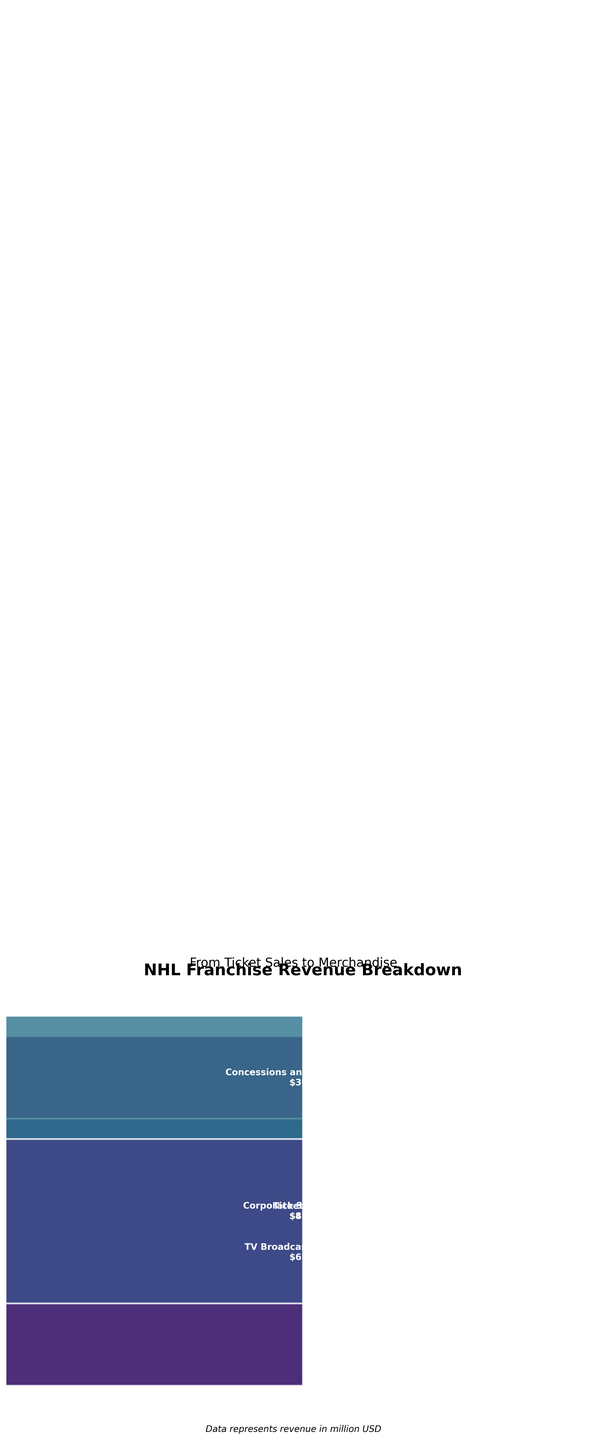What's the largest revenue stage displayed in the funnel chart? The funnel chart shows the breakdown of revenue from various stages, with the largest stage represented by the widest segment at the top. Observing the chart, the largest revenue stage is the first segment, which is labeled "Ticket Sales." The value provided is $85 million.
Answer: Ticket Sales What is the total revenue from concessions, merchandise sales, and parking fees? To find the total revenue from these three stages, we need to sum the values provided in the funnel chart: Concessions and Food Services generate $30 million, Merchandise Sales generate $25 million, and Parking Fees generate $10 million. The sum is 30 + 25 + 10.
Answer: $65 million Which stage has a higher revenue: Corporate Sponsorships or TV Broadcasting Rights? By comparing the height (and label) of the funnel segments, we see Corporate Sponsorships generate $45 million, whereas TV Broadcasting Rights generate $65 million. Therefore, TV Broadcasting Rights has a higher revenue.
Answer: TV Broadcasting Rights What is the average revenue of all the stages? To compute the average, we sum the revenue of all stages and divide by the number of stages. The total revenue is $85M + $65M + $45M + $30M + $25M + $10M + $8M + $5M = $273 million. There are 8 stages, so the average is 273 / 8.
Answer: $34.125 million By how much do ticket sales exceed merchandise sales? To determine this, we subtract the revenue from Merchandise Sales from Ticket Sales. Ticket Sales generates $85 million, and Merchandise Sales generates $25 million. The difference is 85 - 25.
Answer: $60 million What is the smallest revenue segment and its value? The smallest revenue segment can be identified as the narrowest segment at the bottom of the funnel chart. According to the chart, this is the "Special Events and Promotions" stage with a value of $5 million.
Answer: Special Events and Promotions What percentage of the total revenue is contributed by TV Broadcasting Rights? First, we know the total revenue is $273 million. TV Broadcasting Rights contribute $65 million. To find the percentage, we calculate (65 / 273) * 100.
Answer: 23.81% How much more revenue does TV Broadcasting Rights generate than Corporate Sponsorships? We subtract the revenue of Corporate Sponsorships from TV Broadcasting Rights. TV Broadcasting Rights generate $65 million, and Corporate Sponsorships generate $45 million. The difference is 65 - 45.
Answer: $20 million What are the two largest sources of revenue, and what is their combined value? The two largest sources of revenue are the top two segments in the funnel chart, which are "Ticket Sales" with $85 million and "TV Broadcasting Rights" with $65 million. Their combined value is 85 + 65.
Answer: $150 million 